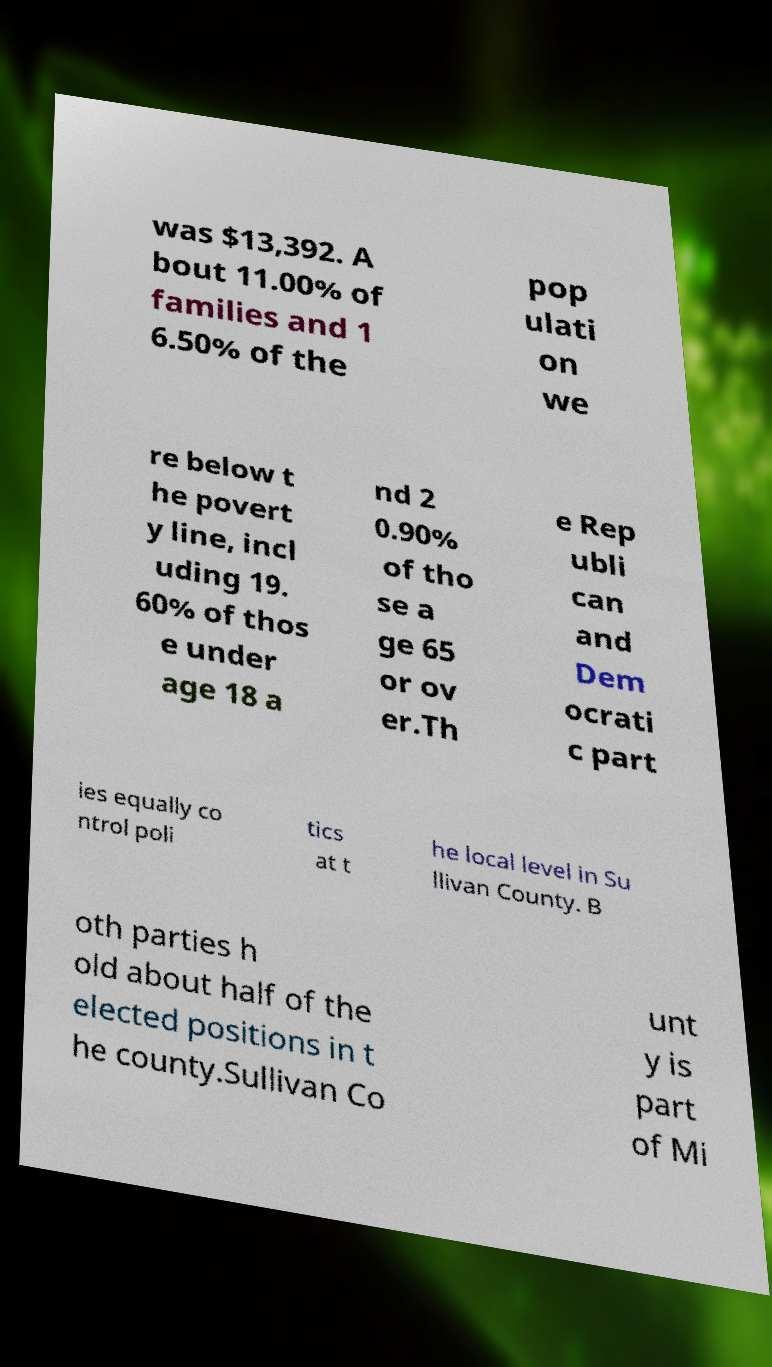Can you read and provide the text displayed in the image?This photo seems to have some interesting text. Can you extract and type it out for me? was $13,392. A bout 11.00% of families and 1 6.50% of the pop ulati on we re below t he povert y line, incl uding 19. 60% of thos e under age 18 a nd 2 0.90% of tho se a ge 65 or ov er.Th e Rep ubli can and Dem ocrati c part ies equally co ntrol poli tics at t he local level in Su llivan County. B oth parties h old about half of the elected positions in t he county.Sullivan Co unt y is part of Mi 